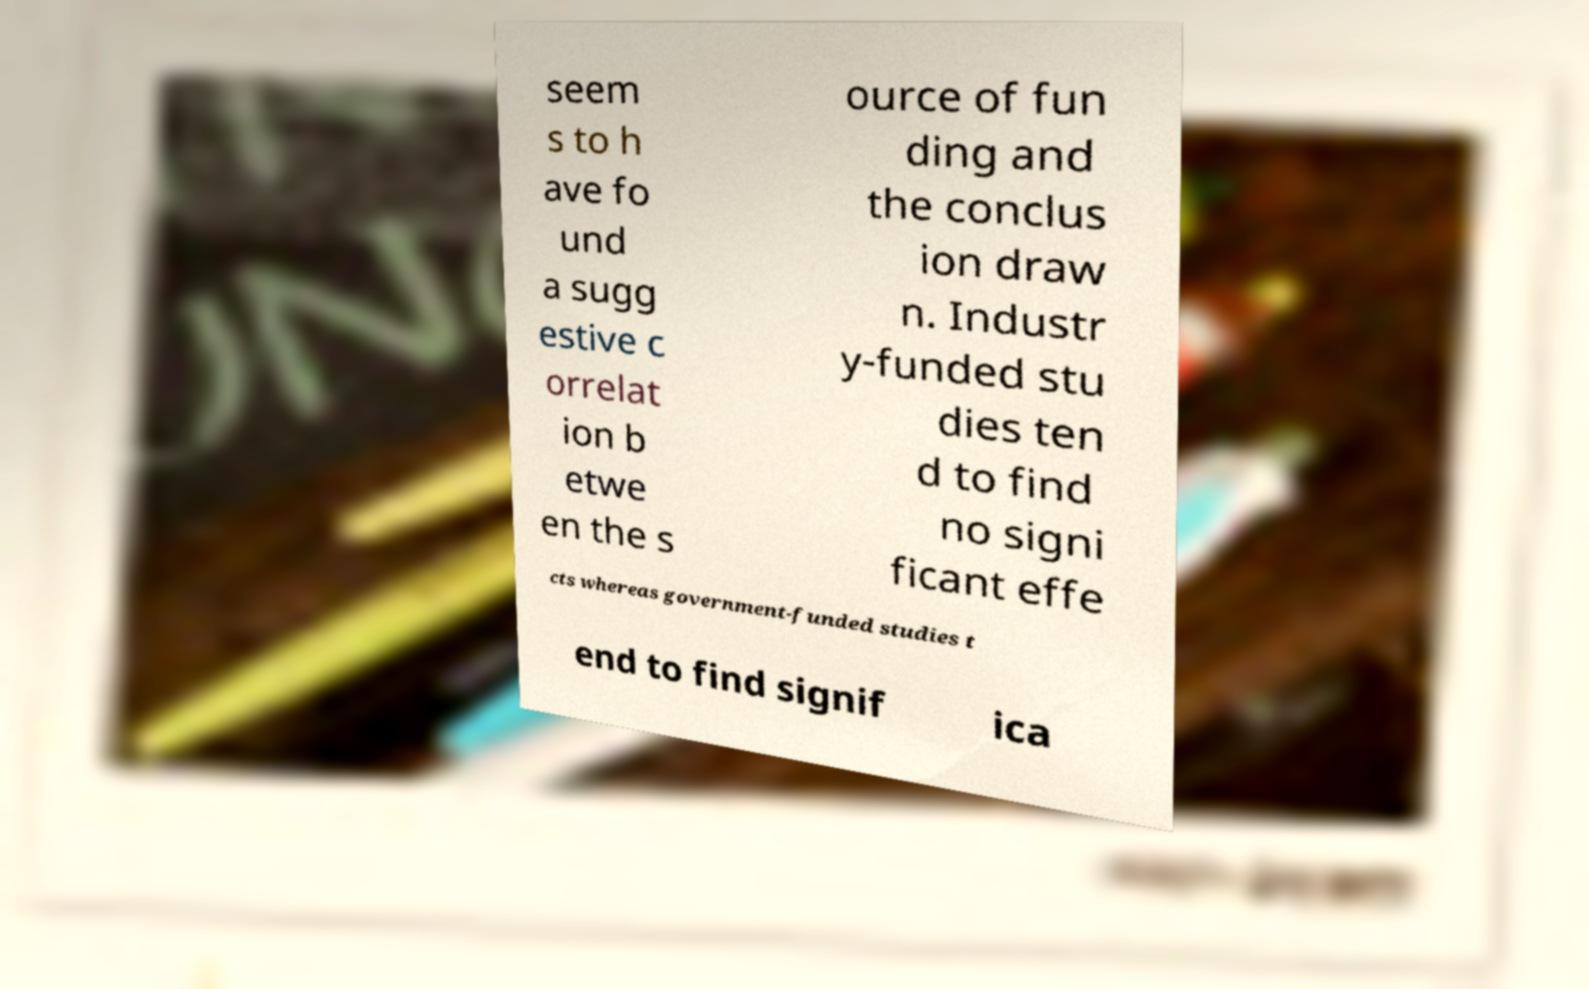Please identify and transcribe the text found in this image. seem s to h ave fo und a sugg estive c orrelat ion b etwe en the s ource of fun ding and the conclus ion draw n. Industr y-funded stu dies ten d to find no signi ficant effe cts whereas government-funded studies t end to find signif ica 